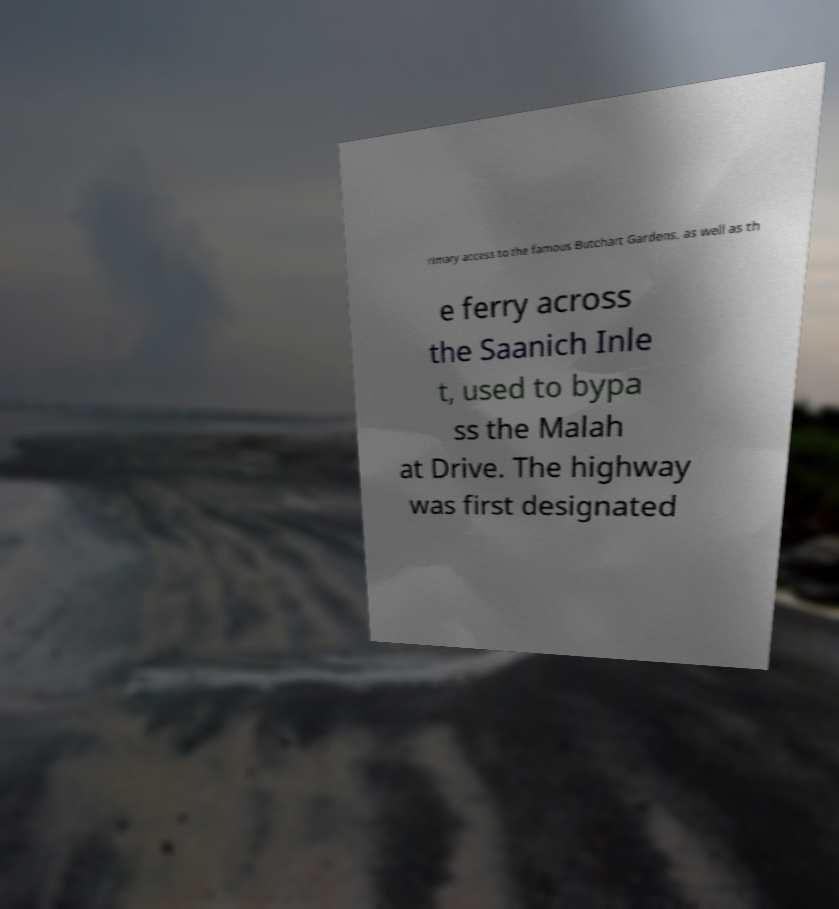For documentation purposes, I need the text within this image transcribed. Could you provide that? rimary access to the famous Butchart Gardens, as well as th e ferry across the Saanich Inle t, used to bypa ss the Malah at Drive. The highway was first designated 